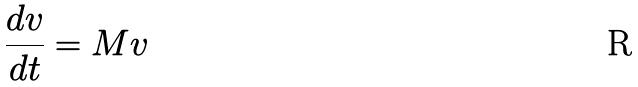Convert formula to latex. <formula><loc_0><loc_0><loc_500><loc_500>\frac { d v } { d t } = M v</formula> 